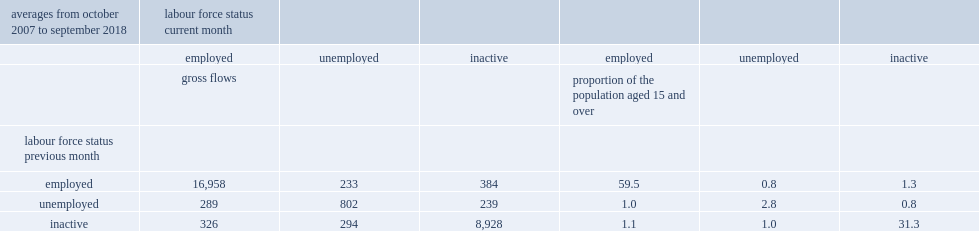How many workers on average remained employed in the subsequent month? 16958.0. Almost 17 million workers, remained employed in the subsequent month, what the percentage of the population aged 15 and over? 59.5. 